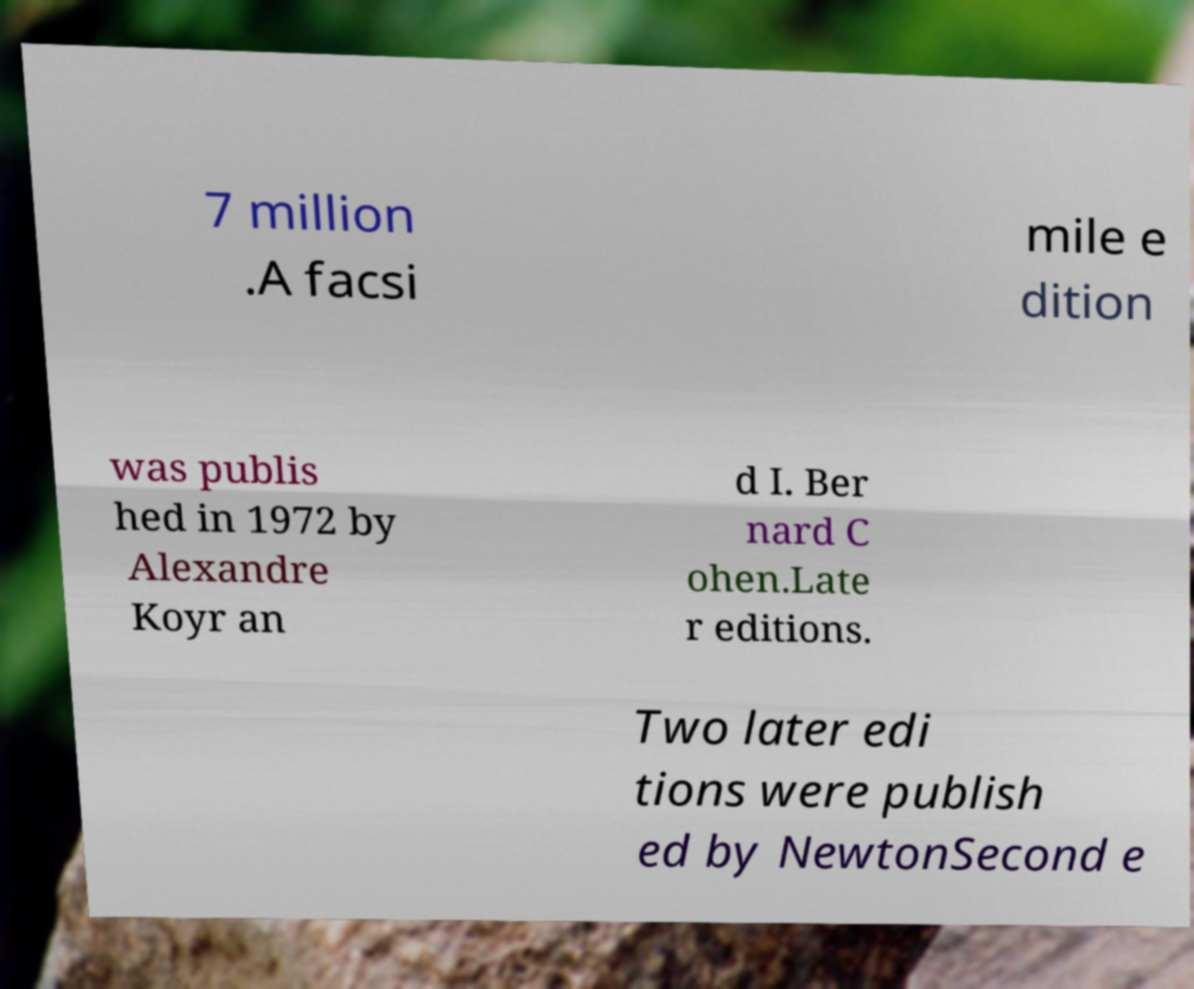Please identify and transcribe the text found in this image. 7 million .A facsi mile e dition was publis hed in 1972 by Alexandre Koyr an d I. Ber nard C ohen.Late r editions. Two later edi tions were publish ed by NewtonSecond e 